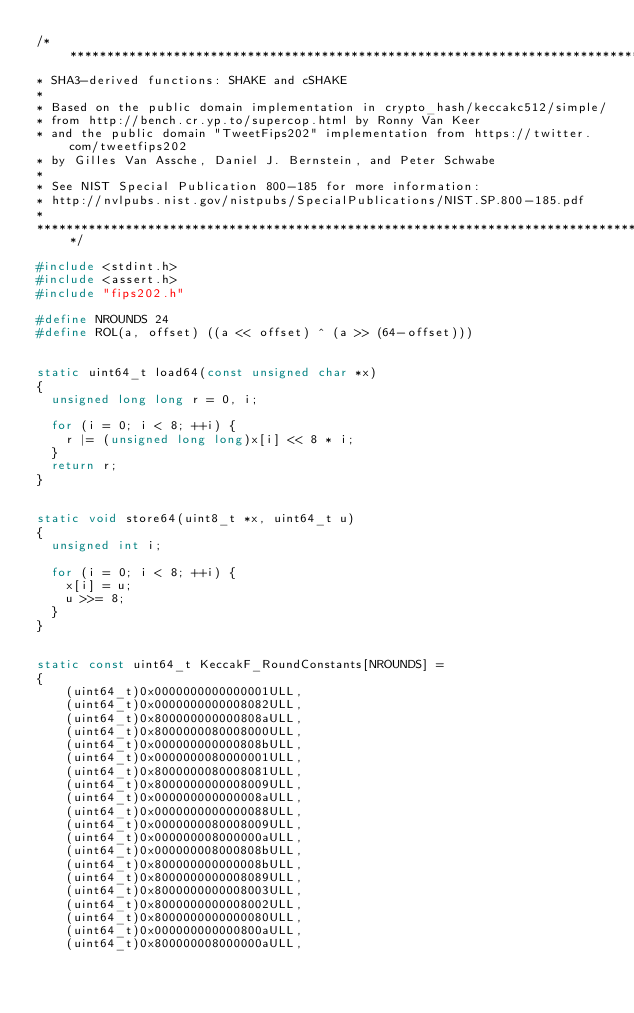<code> <loc_0><loc_0><loc_500><loc_500><_C_>/********************************************************************************************
* SHA3-derived functions: SHAKE and cSHAKE
*
* Based on the public domain implementation in crypto_hash/keccakc512/simple/ 
* from http://bench.cr.yp.to/supercop.html by Ronny Van Keer 
* and the public domain "TweetFips202" implementation from https://twitter.com/tweetfips202 
* by Gilles Van Assche, Daniel J. Bernstein, and Peter Schwabe
*
* See NIST Special Publication 800-185 for more information:
* http://nvlpubs.nist.gov/nistpubs/SpecialPublications/NIST.SP.800-185.pdf
*
*********************************************************************************************/  

#include <stdint.h>
#include <assert.h>
#include "fips202.h"

#define NROUNDS 24
#define ROL(a, offset) ((a << offset) ^ (a >> (64-offset)))


static uint64_t load64(const unsigned char *x)
{
  unsigned long long r = 0, i;

  for (i = 0; i < 8; ++i) {
    r |= (unsigned long long)x[i] << 8 * i;
  }
  return r;
}


static void store64(uint8_t *x, uint64_t u)
{
  unsigned int i;

  for (i = 0; i < 8; ++i) {
    x[i] = u;
    u >>= 8;
  }
}


static const uint64_t KeccakF_RoundConstants[NROUNDS] = 
{
    (uint64_t)0x0000000000000001ULL,
    (uint64_t)0x0000000000008082ULL,
    (uint64_t)0x800000000000808aULL,
    (uint64_t)0x8000000080008000ULL,
    (uint64_t)0x000000000000808bULL,
    (uint64_t)0x0000000080000001ULL,
    (uint64_t)0x8000000080008081ULL,
    (uint64_t)0x8000000000008009ULL,
    (uint64_t)0x000000000000008aULL,
    (uint64_t)0x0000000000000088ULL,
    (uint64_t)0x0000000080008009ULL,
    (uint64_t)0x000000008000000aULL,
    (uint64_t)0x000000008000808bULL,
    (uint64_t)0x800000000000008bULL,
    (uint64_t)0x8000000000008089ULL,
    (uint64_t)0x8000000000008003ULL,
    (uint64_t)0x8000000000008002ULL,
    (uint64_t)0x8000000000000080ULL,
    (uint64_t)0x000000000000800aULL,
    (uint64_t)0x800000008000000aULL,</code> 